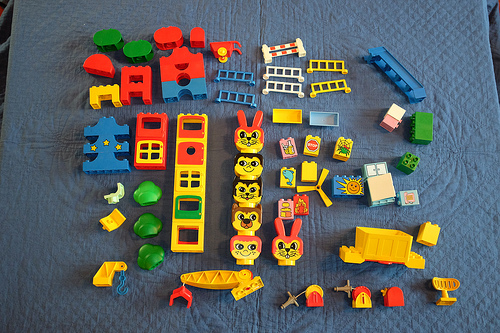<image>
Can you confirm if the bunnies is above the hook? No. The bunnies is not positioned above the hook. The vertical arrangement shows a different relationship. 